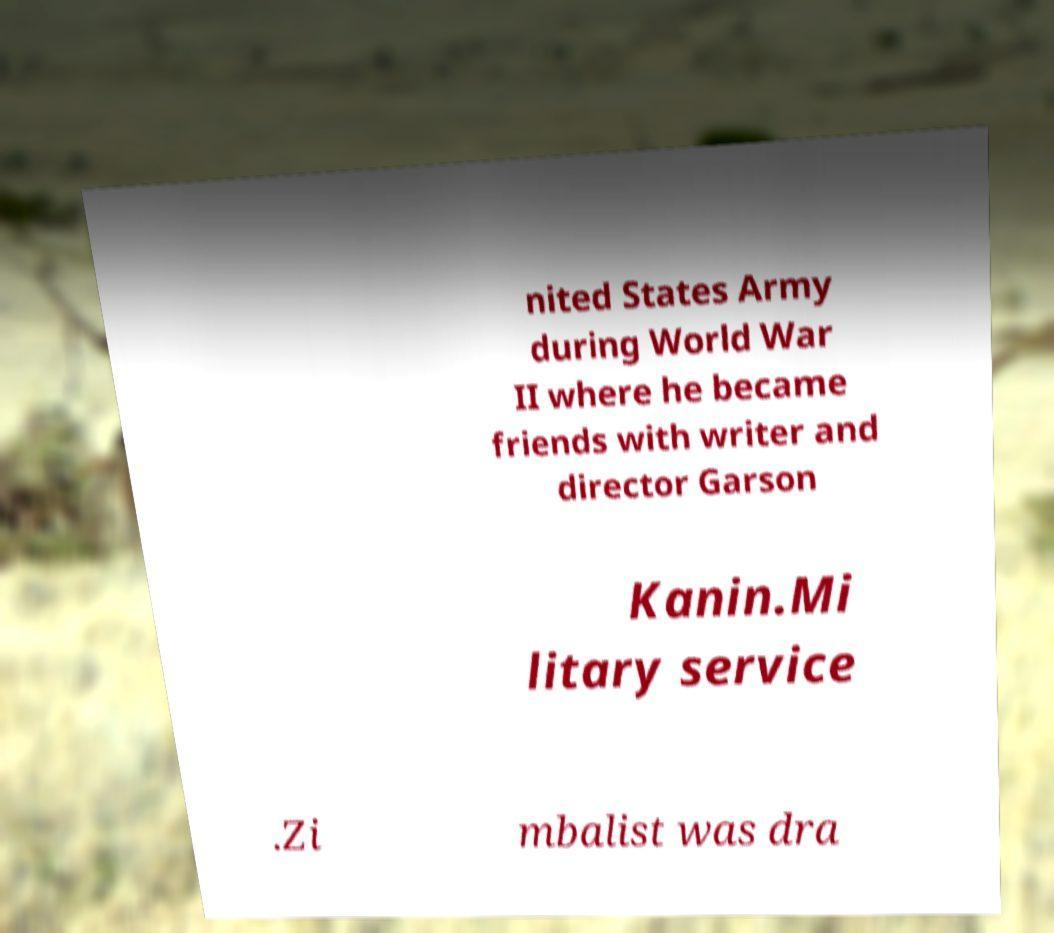Could you assist in decoding the text presented in this image and type it out clearly? nited States Army during World War II where he became friends with writer and director Garson Kanin.Mi litary service .Zi mbalist was dra 